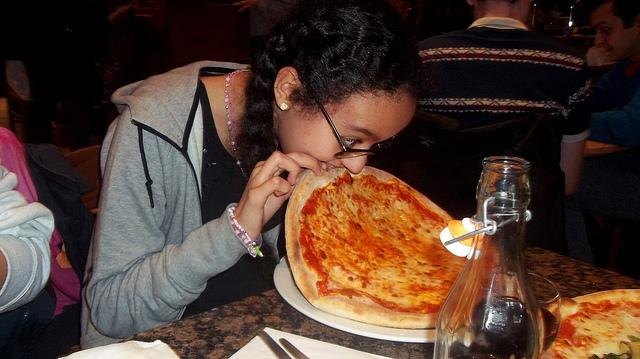What would most people do first before biting their pizza? cut it 